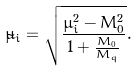Convert formula to latex. <formula><loc_0><loc_0><loc_500><loc_500>\tilde { \mu } _ { i } = \sqrt { \frac { \mu _ { i } ^ { 2 } - M _ { 0 } ^ { 2 } } { 1 + \frac { M _ { 0 } } { M _ { q } } } } .</formula> 